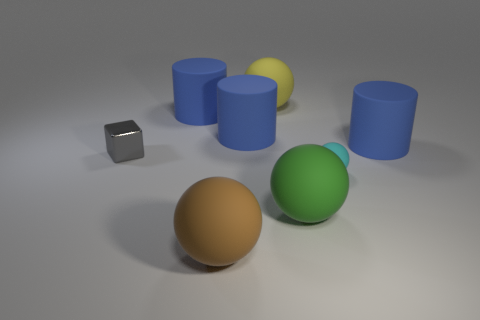Subtract 1 spheres. How many spheres are left? 3 Add 2 yellow balls. How many objects exist? 10 Subtract all purple spheres. Subtract all gray cylinders. How many spheres are left? 4 Subtract all cubes. How many objects are left? 7 Subtract all small cyan spheres. Subtract all tiny things. How many objects are left? 5 Add 3 small cyan balls. How many small cyan balls are left? 4 Add 6 brown things. How many brown things exist? 7 Subtract 0 blue cubes. How many objects are left? 8 